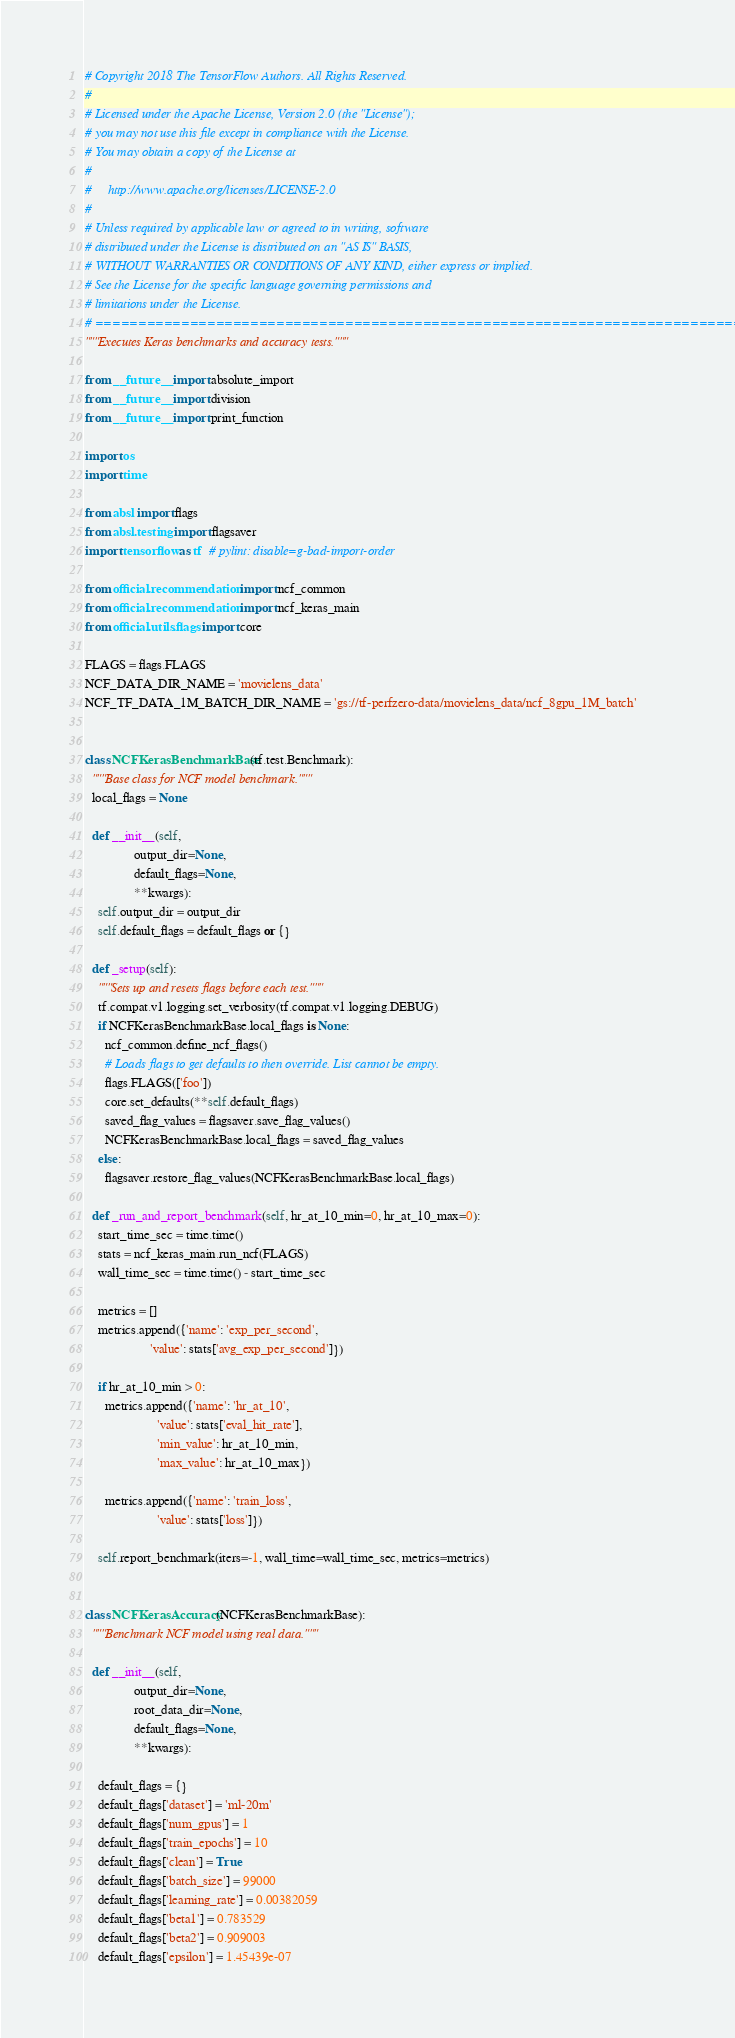Convert code to text. <code><loc_0><loc_0><loc_500><loc_500><_Python_># Copyright 2018 The TensorFlow Authors. All Rights Reserved.
#
# Licensed under the Apache License, Version 2.0 (the "License");
# you may not use this file except in compliance with the License.
# You may obtain a copy of the License at
#
#     http://www.apache.org/licenses/LICENSE-2.0
#
# Unless required by applicable law or agreed to in writing, software
# distributed under the License is distributed on an "AS IS" BASIS,
# WITHOUT WARRANTIES OR CONDITIONS OF ANY KIND, either express or implied.
# See the License for the specific language governing permissions and
# limitations under the License.
# ==============================================================================
"""Executes Keras benchmarks and accuracy tests."""

from __future__ import absolute_import
from __future__ import division
from __future__ import print_function

import os
import time

from absl import flags
from absl.testing import flagsaver
import tensorflow as tf  # pylint: disable=g-bad-import-order

from official.recommendation import ncf_common
from official.recommendation import ncf_keras_main
from official.utils.flags import core

FLAGS = flags.FLAGS
NCF_DATA_DIR_NAME = 'movielens_data'
NCF_TF_DATA_1M_BATCH_DIR_NAME = 'gs://tf-perfzero-data/movielens_data/ncf_8gpu_1M_batch'


class NCFKerasBenchmarkBase(tf.test.Benchmark):
  """Base class for NCF model benchmark."""
  local_flags = None

  def __init__(self,
               output_dir=None,
               default_flags=None,
               **kwargs):
    self.output_dir = output_dir
    self.default_flags = default_flags or {}

  def _setup(self):
    """Sets up and resets flags before each test."""
    tf.compat.v1.logging.set_verbosity(tf.compat.v1.logging.DEBUG)
    if NCFKerasBenchmarkBase.local_flags is None:
      ncf_common.define_ncf_flags()
      # Loads flags to get defaults to then override. List cannot be empty.
      flags.FLAGS(['foo'])
      core.set_defaults(**self.default_flags)
      saved_flag_values = flagsaver.save_flag_values()
      NCFKerasBenchmarkBase.local_flags = saved_flag_values
    else:
      flagsaver.restore_flag_values(NCFKerasBenchmarkBase.local_flags)

  def _run_and_report_benchmark(self, hr_at_10_min=0, hr_at_10_max=0):
    start_time_sec = time.time()
    stats = ncf_keras_main.run_ncf(FLAGS)
    wall_time_sec = time.time() - start_time_sec

    metrics = []
    metrics.append({'name': 'exp_per_second',
                    'value': stats['avg_exp_per_second']})

    if hr_at_10_min > 0:
      metrics.append({'name': 'hr_at_10',
                      'value': stats['eval_hit_rate'],
                      'min_value': hr_at_10_min,
                      'max_value': hr_at_10_max})

      metrics.append({'name': 'train_loss',
                      'value': stats['loss']})

    self.report_benchmark(iters=-1, wall_time=wall_time_sec, metrics=metrics)


class NCFKerasAccuracy(NCFKerasBenchmarkBase):
  """Benchmark NCF model using real data."""

  def __init__(self,
               output_dir=None,
               root_data_dir=None,
               default_flags=None,
               **kwargs):

    default_flags = {}
    default_flags['dataset'] = 'ml-20m'
    default_flags['num_gpus'] = 1
    default_flags['train_epochs'] = 10
    default_flags['clean'] = True
    default_flags['batch_size'] = 99000
    default_flags['learning_rate'] = 0.00382059
    default_flags['beta1'] = 0.783529
    default_flags['beta2'] = 0.909003
    default_flags['epsilon'] = 1.45439e-07</code> 